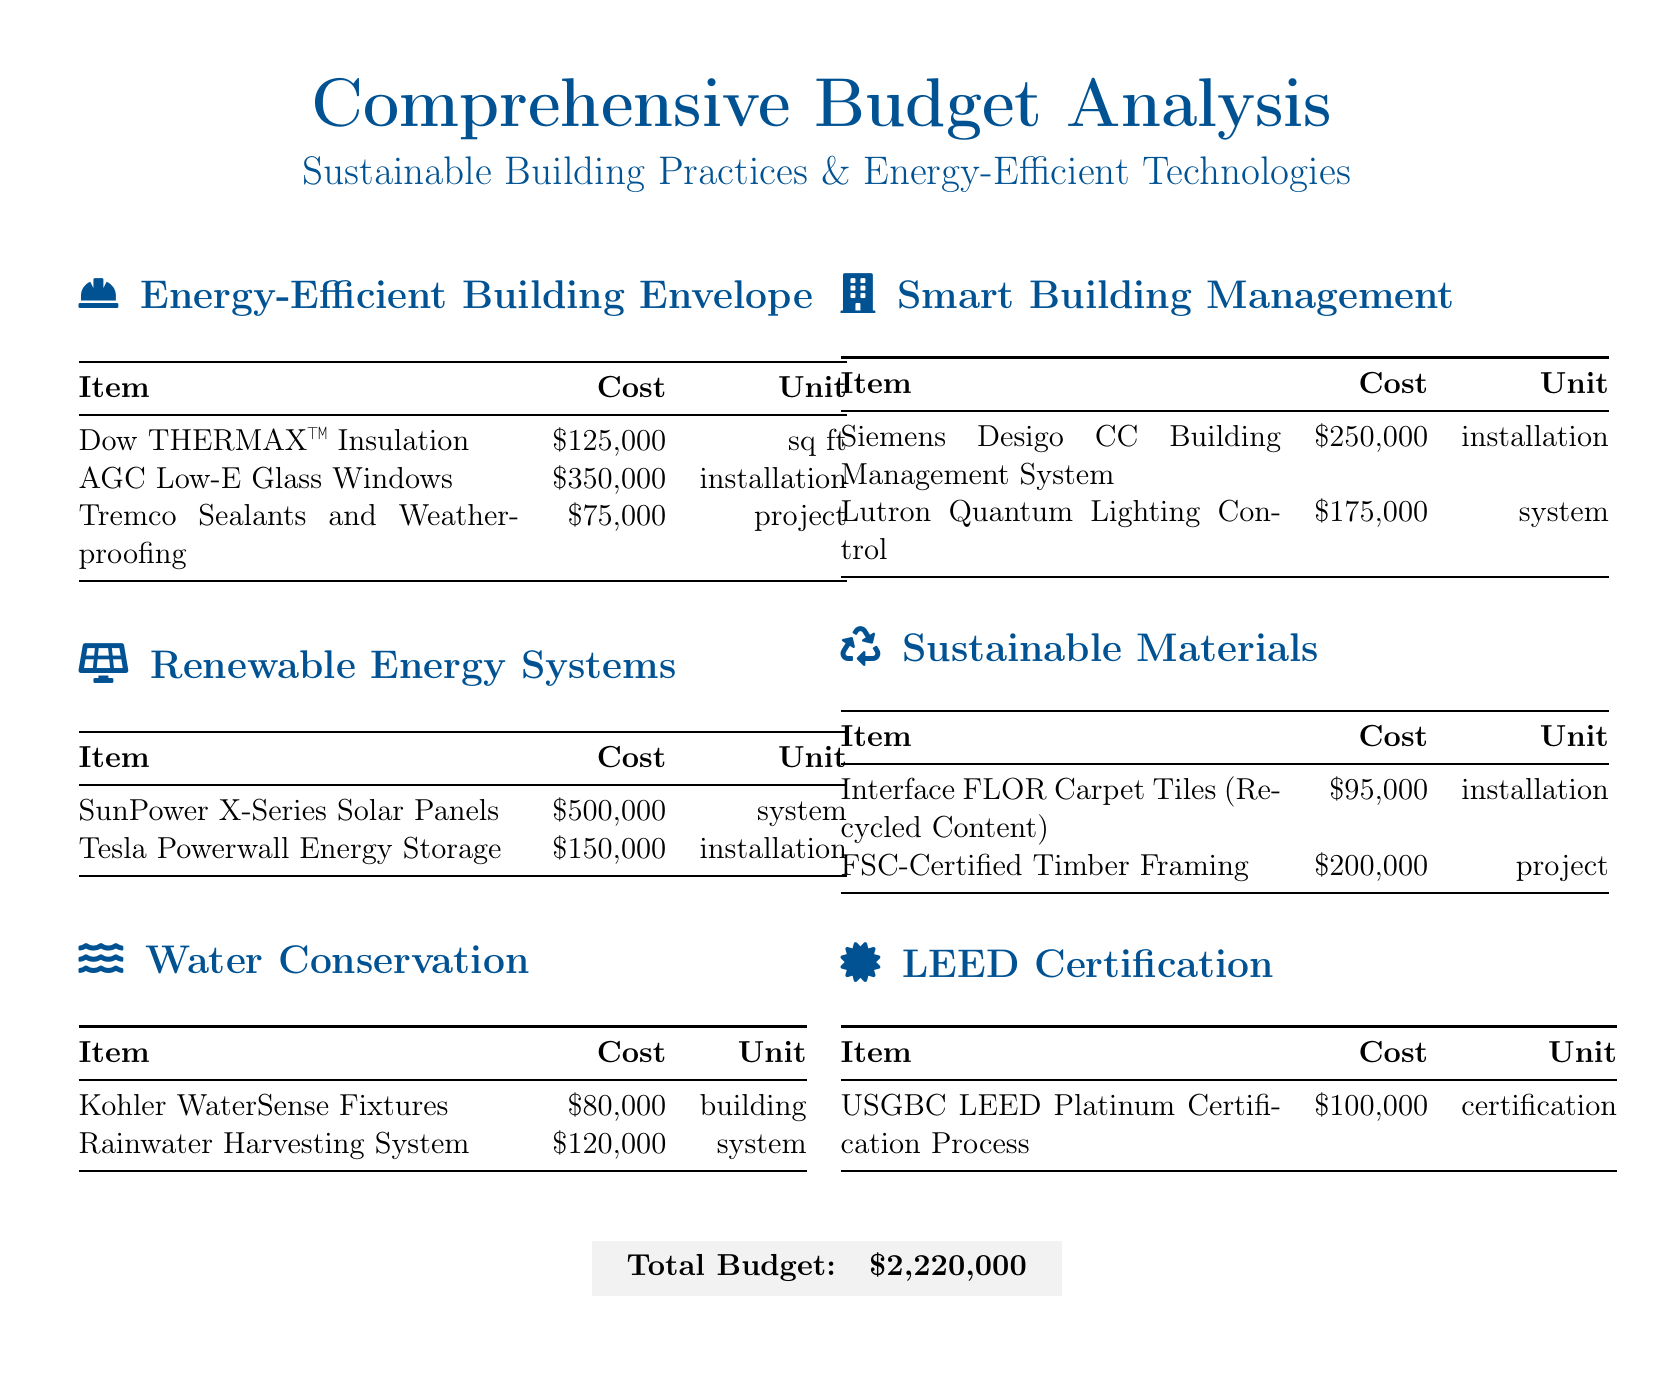What is the total budget? The total budget is listed at the end of the document as the sum of all costs presented.
Answer: $2,220,000 How much does the Tesla Powerwall Energy Storage cost? The budget specifies a particular cost for the Tesla Powerwall Energy Storage under the Renewable Energy Systems section.
Answer: $150,000 What type of certification is included in the budget? The document references a specific certification related to sustainability, named in the LEED Certification section.
Answer: USGBC LEED Platinum Certification Which item under Sustainable Materials has the lowest cost? The costs associated with items under Sustainable Materials are needed to find the one with the lowest value.
Answer: $95,000 How many units of the AGC Low-E Glass Windows are included in the budget? The document specifies the unit for the AGC Low-E Glass Windows in the budget table.
Answer: installation What is the cost for rainwater harvesting systems? The budget indicates a specific cost associated with rainwater harvesting systems under Water Conservation.
Answer: $120,000 What is the cost of the Siemens Desigo CC Building Management System? The Siemens Desigo CC Building Management System is detailed in the Smart Building Management section with a specific cost.
Answer: $250,000 Which item has a cost of $350,000? By examining the Renewable Energy Systems section, one can find the corresponding cost for a specific item.
Answer: AGC Low-E Glass Windows What is the cost of installing Kohler WaterSense Fixtures? The document specifies the total cost allocated for the installation of Kohler WaterSense Fixtures.
Answer: $80,000 